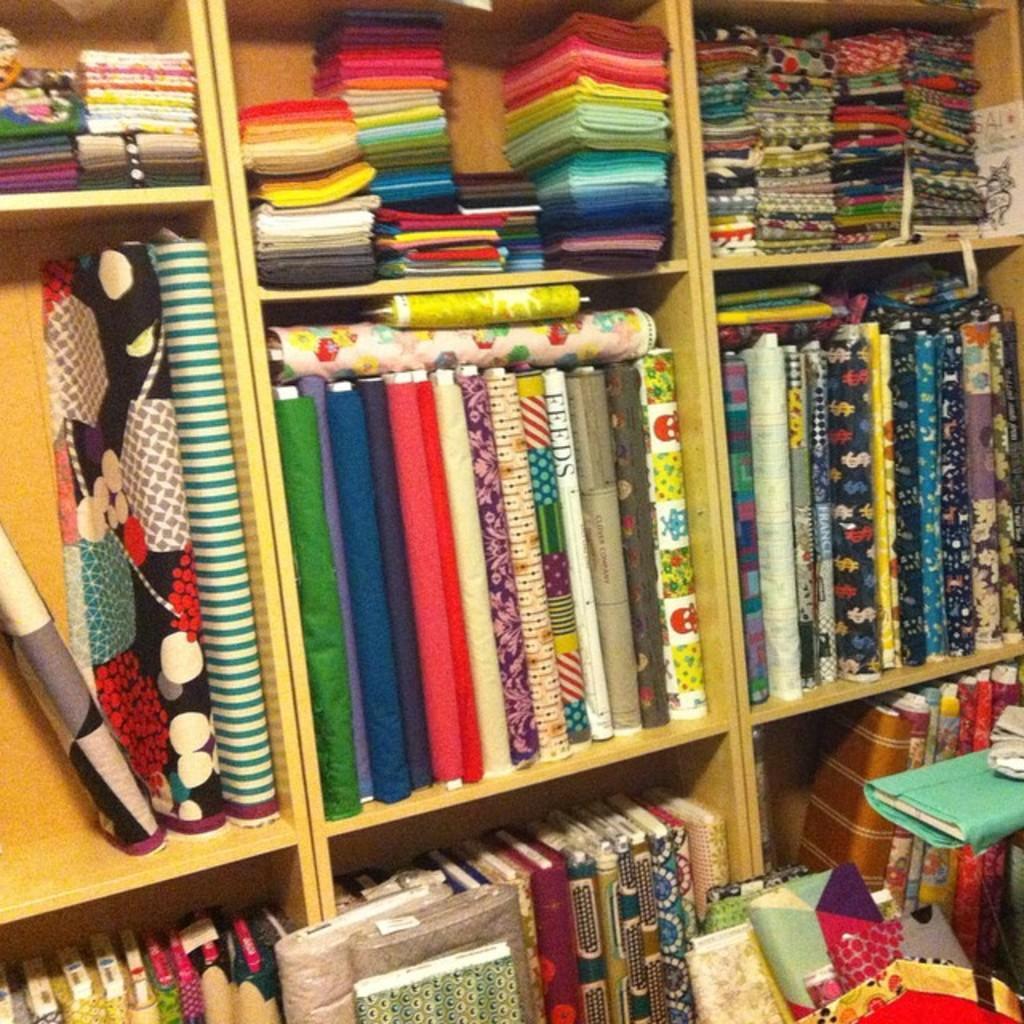Can you describe this image briefly? There are clothes in different colors arranged on the wooden shelves. On the right side, there are clothes on the floor. 